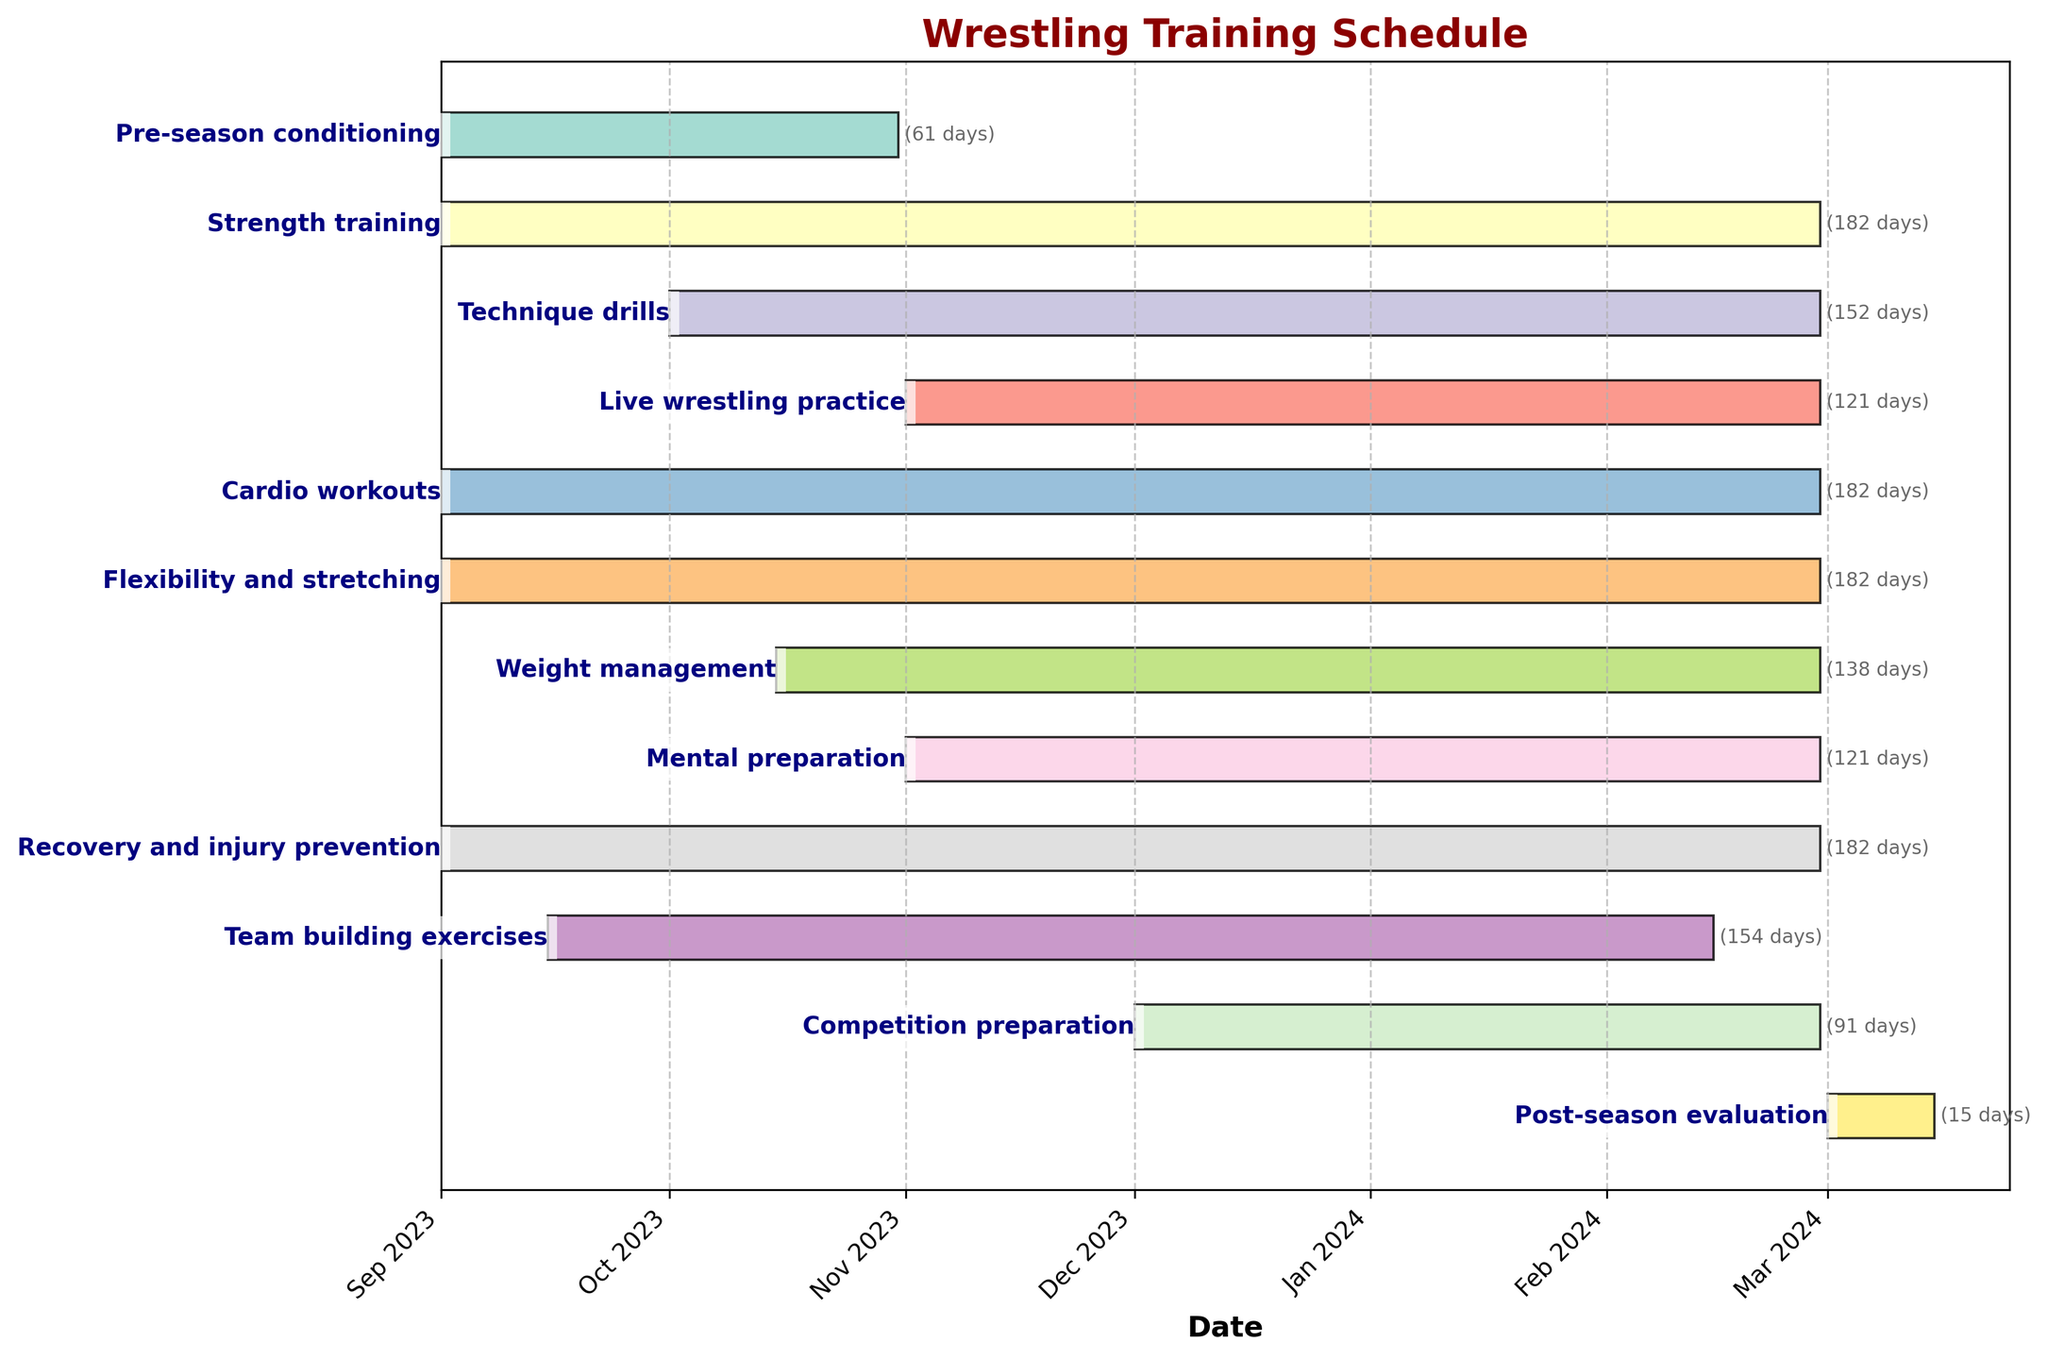What's the title of the Gantt Chart? The title of the Gantt Chart is displayed at the top of the figure.
Answer: Wrestling Training Schedule How long is the Pre-season conditioning period? The Gantt Chart shows that Pre-season conditioning starts on 2023-09-01 and ends on 2023-10-31. Subtracting these dates gives 61 days.
Answer: 61 days Which training activity lasts the longest? The duration of each activity is shown alongside the bars. Strength training, Cardio workouts, Flexibility and stretching, Recovery and injury prevention all last for 182 days.
Answer: Strength training, Cardio workouts, Flexibility and stretching, Recovery and injury prevention What are the start and end dates for Live wrestling practice? The Gantt Chart shows that Live wrestling practice starts on 2023-11-01 and ends on 2024-02-29.
Answer: 2023-11-01 to 2024-02-29 How many days of training are allocated to Post-season evaluation? The Gantt Chart indicates that Post-season evaluation lasts from 2024-03-01 to 2024-03-15, which is 15 days.
Answer: 15 days Which activities start in September 2023? The Gantt Chart shows multiple activities starting in September 2023: Pre-season conditioning, Strength training, Cardio workouts, Flexibility and stretching, Recovery and injury prevention, Team building exercises.
Answer: Six activities What is the overlap duration between Technique drills and Weight management? Technique drills start on 2023-10-01 and Weight management starts on 2023-10-15. Both end on 2024-02-29. The overlap period is 2023-10-15 to 2024-02-29, which is 138 days.
Answer: 138 days How many months does the Competition preparation last? The Competition preparation starts on 2023-12-01 and ends on 2024-02-29. The entire month of December, January, and February counts as three months.
Answer: 3 months Which two activities end latest in the schedule? The Gantt Chart shows that the latest end date is 2024-03-15. Post-season evaluation ends on this date. Others end earlier.
Answer: Post-season evaluation Between Mental preparation and Team building exercises, which activity lasts shorter, and by how many days? Mental preparation lasts from 2023-11-01 to 2024-02-29 for 121 days, and Team building exercises last from 2023-09-15 to 2024-02-15 for 154 days. Team building exercises lasts 33 days longer (154 - 121).
Answer: Mental preparation lasts shorter by 33 days 